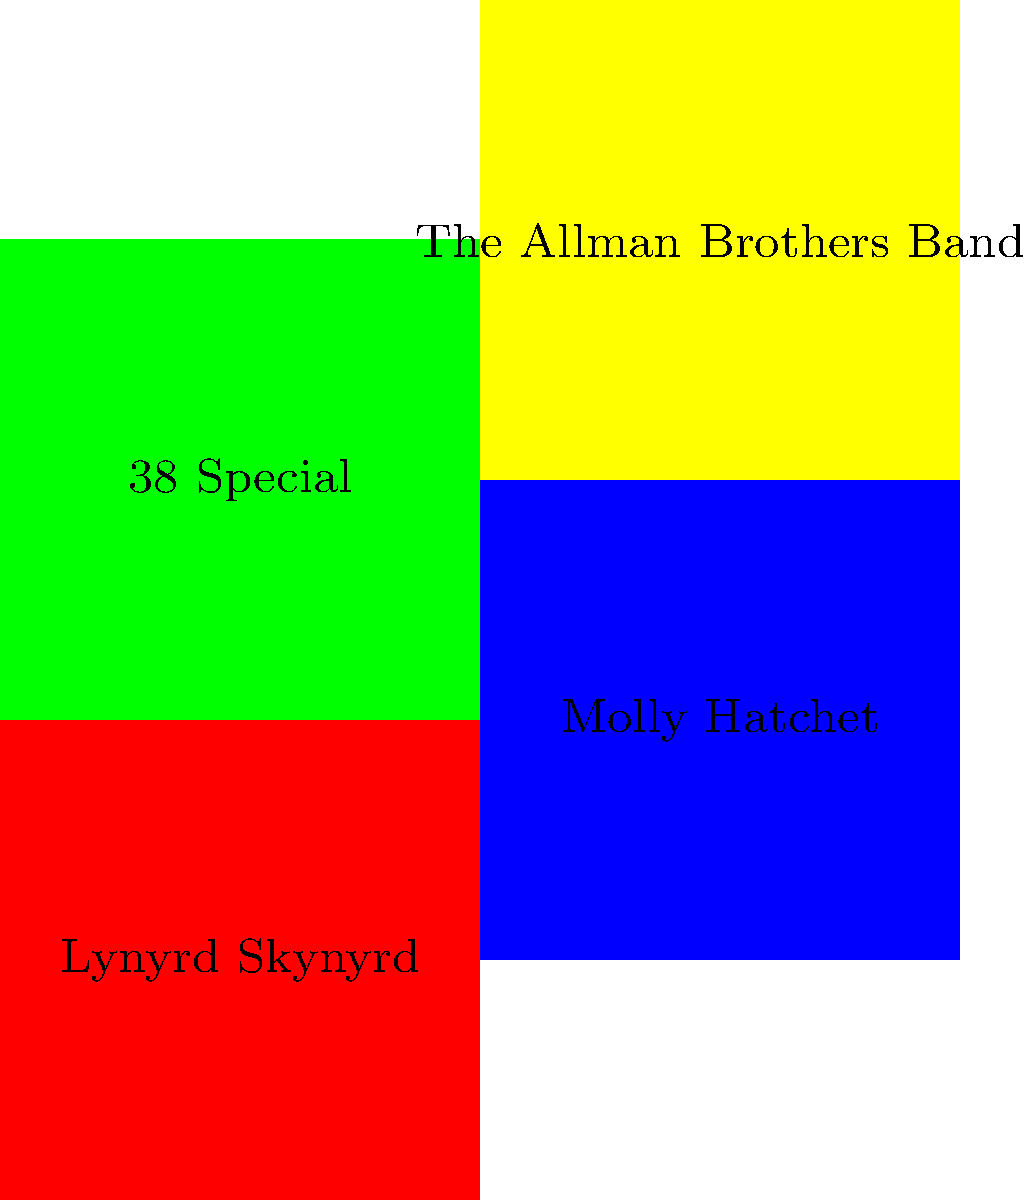Which color represents the logo of the band that famously performed "Sweet Home Alabama"? To answer this question, let's follow these steps:

1. Identify the band that performed "Sweet Home Alabama":
   "Sweet Home Alabama" is one of the most famous songs by Lynyrd Skynyrd.

2. Locate Lynyrd Skynyrd on the graphic:
   Lynyrd Skynyrd is listed in the top-left quadrant of the image.

3. Determine the color associated with Lynyrd Skynyrd:
   The color filling the quadrant where Lynyrd Skynyrd is listed is red.

Therefore, the color representing the logo of the band that famously performed "Sweet Home Alabama" is red.
Answer: Red 